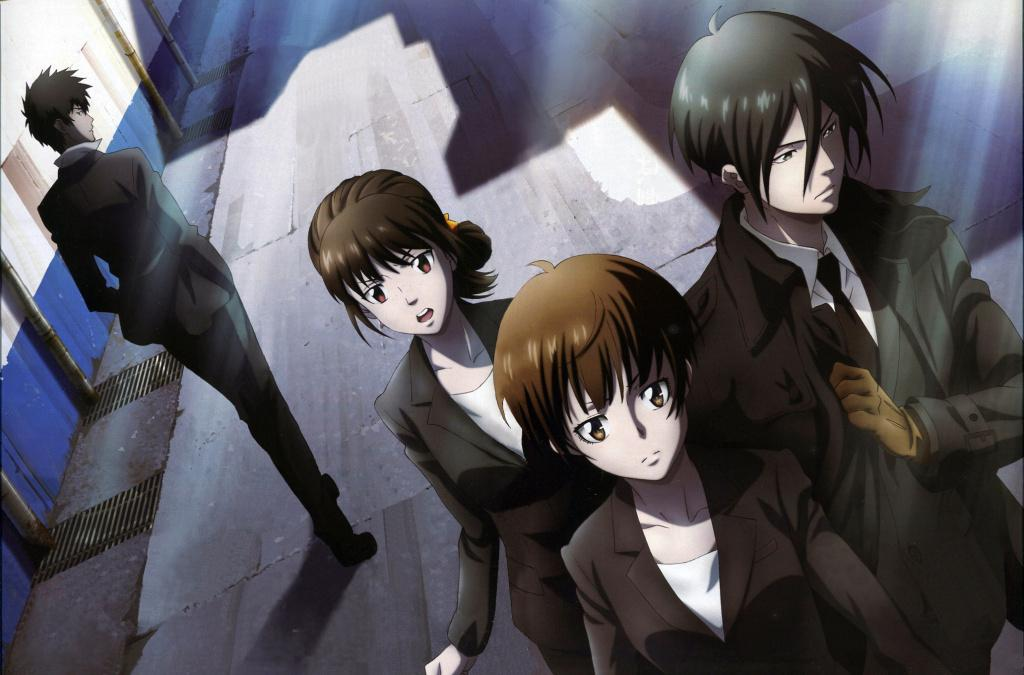What type of images are on the floor in the image? There are cartoon images of persons on the floor. What can be seen in the background of the image? There is a wall and poles in the background of the image. How many cups of rice are being served to the cartoon characters in the image? There is no rice present in the image, and the cartoon characters are not being served any food. 